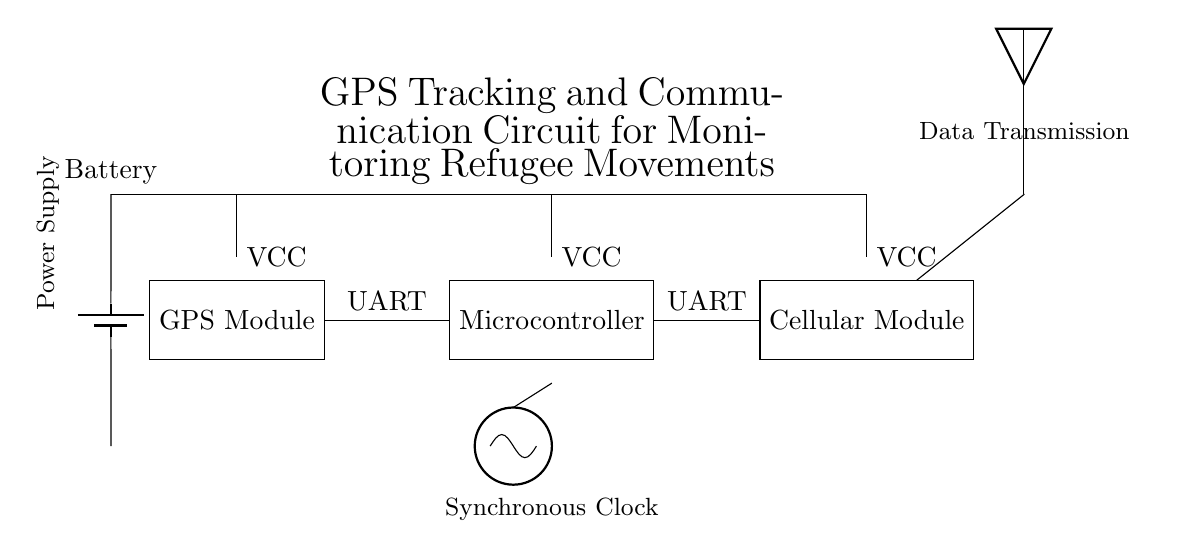What components are present in the circuit? The components listed in the circuit diagram include a GPS Module, Microcontroller, Cellular Module, Antenna, Battery, and an Oscillator. These can be found by identifying each labeled block in the diagram.
Answer: GPS Module, Microcontroller, Cellular Module, Antenna, Battery, Oscillator What type of connection is used between the GPS Module and the Microcontroller? The circuit diagram indicates that the connection between the GPS Module and the Microcontroller is labeled as "UART", which stands for Universal Asynchronous Receiver-Transmitter. This can be seen directly on the connecting line.
Answer: UART What is the function of the antenna in this circuit? The antenna is used for data transmission, which is specifically indicated in the diagram next to the antenna component. Its primary role is to send and receive communication signals.
Answer: Data Transmission Which component is responsible for providing power to the circuit? The component responsible for power supply in this circuit is the Battery, as it is drawn at the bottom left and connected with VCC labels to all other components. It provides the required voltage for operation.
Answer: Battery How many UART connections are present in the circuit? The circuit diagram displays two distinct UART connections: one from the GPS Module to the Microcontroller, and another from the Microcontroller to the Cellular Module. By counting these connections, we determine the total.
Answer: Two What is the role of the oscillator in this synchronous circuit? The oscillator provides a clock signal that synchronizes operations within the circuit components, especially the microcontroller, ensuring that data is processed and transmitted at the right times. Its function is essential for synchronous operation.
Answer: Clock Signal What does VCC indicate in the circuit design? VCC stands for "Voltage at Common Collector," which indicates the power supply voltage level to the components in the circuit. In this diagram, it shows that VCC connects the Battery to each module to provide operational voltage.
Answer: Power Supply Voltage 